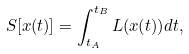<formula> <loc_0><loc_0><loc_500><loc_500>S [ x ( t ) ] = \int ^ { t _ { B } } _ { t _ { A } } L ( x ( t ) ) d t ,</formula> 